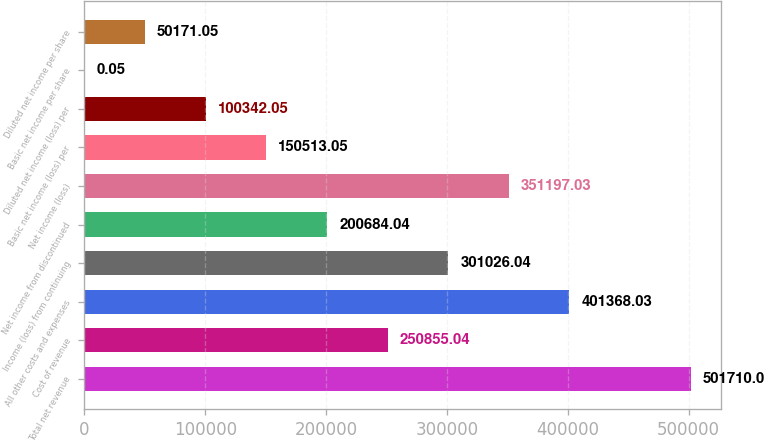<chart> <loc_0><loc_0><loc_500><loc_500><bar_chart><fcel>Total net revenue<fcel>Cost of revenue<fcel>All other costs and expenses<fcel>Income (loss) from continuing<fcel>Net income from discontinued<fcel>Net income (loss)<fcel>Basic net income (loss) per<fcel>Diluted net income (loss) per<fcel>Basic net income per share<fcel>Diluted net income per share<nl><fcel>501710<fcel>250855<fcel>401368<fcel>301026<fcel>200684<fcel>351197<fcel>150513<fcel>100342<fcel>0.05<fcel>50171.1<nl></chart> 